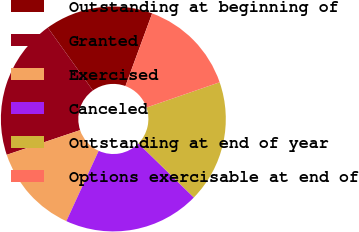<chart> <loc_0><loc_0><loc_500><loc_500><pie_chart><fcel>Outstanding at beginning of<fcel>Granted<fcel>Exercised<fcel>Canceled<fcel>Outstanding at end of year<fcel>Options exercisable at end of<nl><fcel>15.52%<fcel>20.25%<fcel>12.98%<fcel>19.56%<fcel>17.59%<fcel>14.1%<nl></chart> 